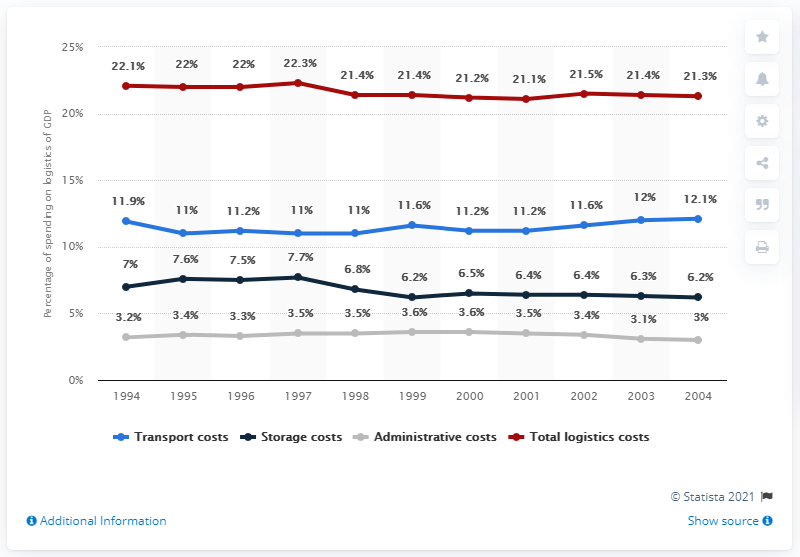Indicate a few pertinent items in this graphic. In 2002, logistics accounted for approximately 11.6% of China's Gross Domestic Product (GDP). In 1994, China began to invest in logistics. 